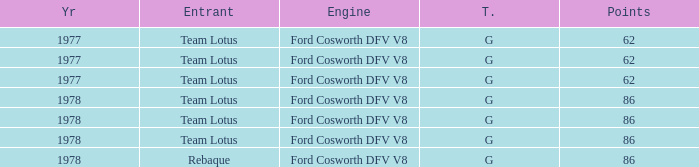What is the Motor that has a Focuses bigger than 62, and a Participant of rebaque? Ford Cosworth DFV V8. 